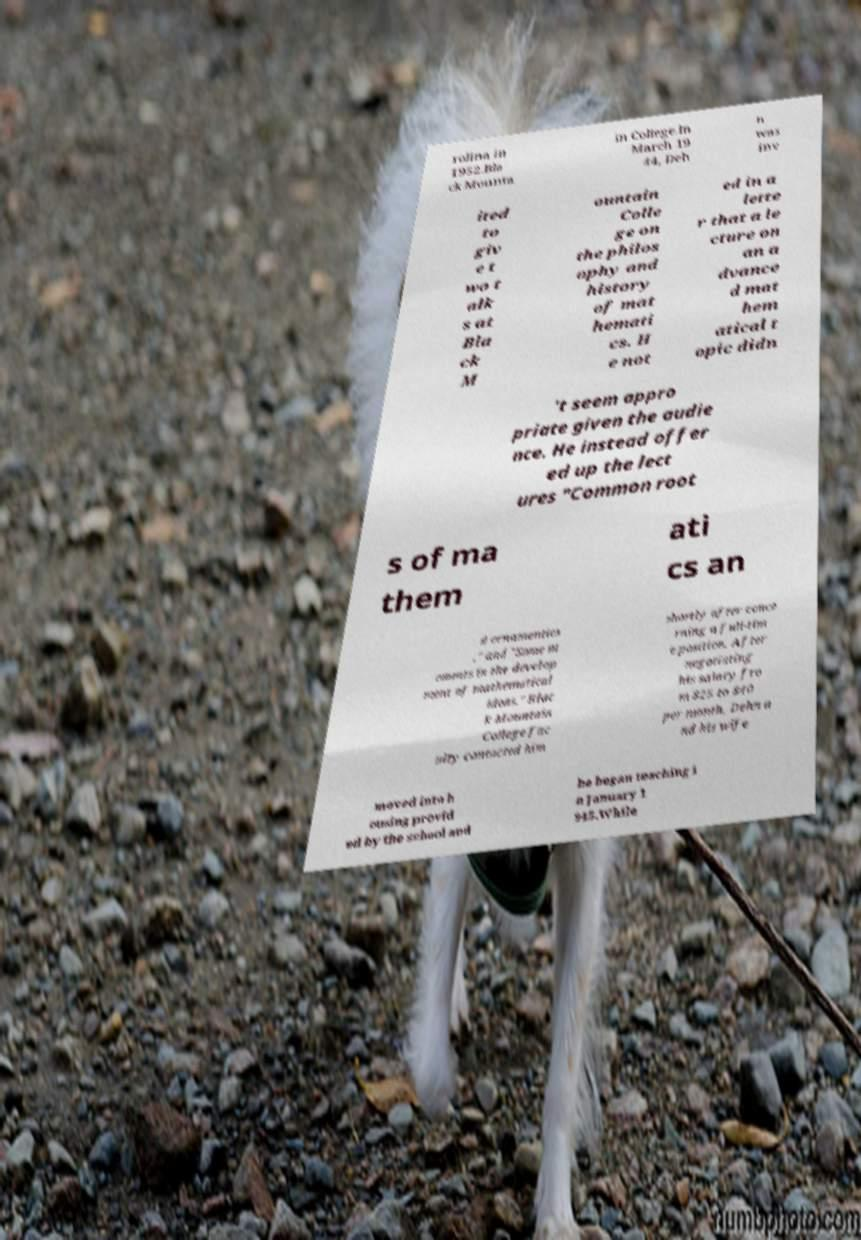I need the written content from this picture converted into text. Can you do that? rolina in 1952.Bla ck Mounta in College.In March 19 44, Deh n was inv ited to giv e t wo t alk s at Bla ck M ountain Colle ge on the philos ophy and history of mat hemati cs. H e not ed in a lette r that a le cture on an a dvance d mat hem atical t opic didn 't seem appro priate given the audie nce. He instead offer ed up the lect ures "Common root s of ma them ati cs an d ornamentics ," and "Some m oments in the develop ment of mathematical ideas." Blac k Mountain College fac ulty contacted him shortly after conce rning a full-tim e position. After negotiating his salary fro m $25 to $40 per month, Dehn a nd his wife moved into h ousing provid ed by the school and he began teaching i n January 1 945.While 